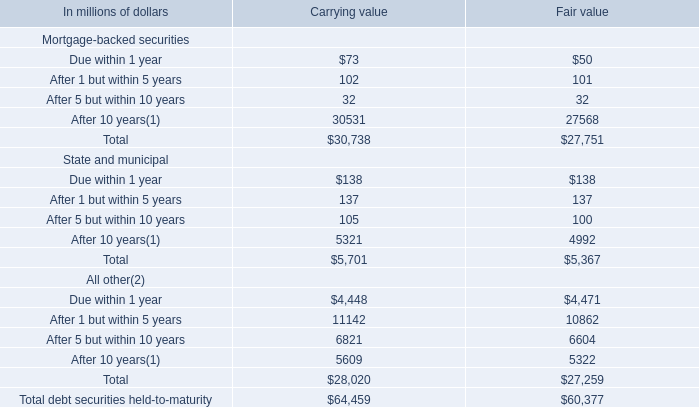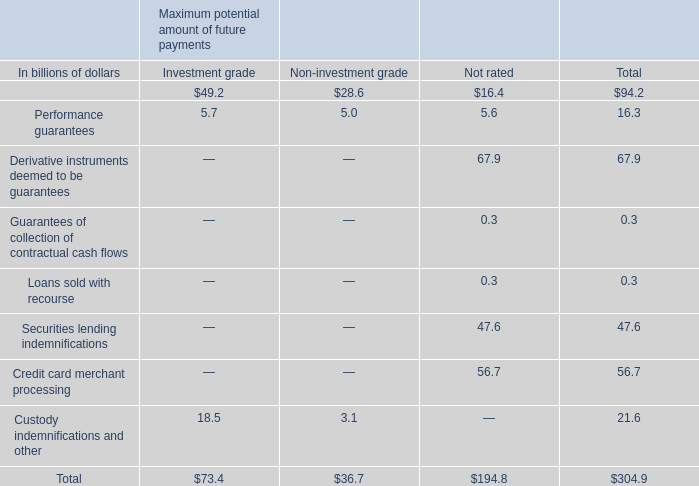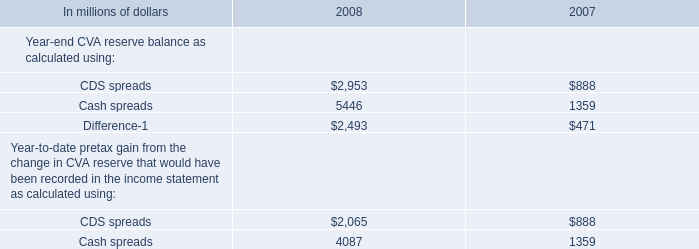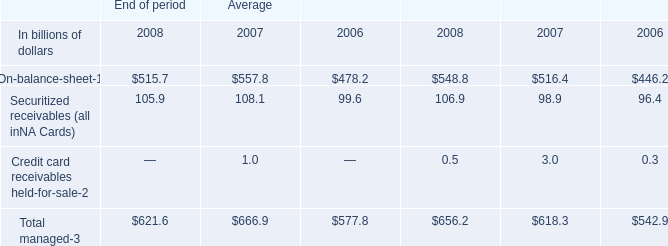what was the percentage increase in citigroup 2019s allowance for loan losses attributable to the consumer portfolio from 2007 to 2008 
Computations: ((22.366 - 12.393) / 12.393)
Answer: 0.80473. 